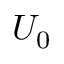Convert formula to latex. <formula><loc_0><loc_0><loc_500><loc_500>U _ { 0 }</formula> 